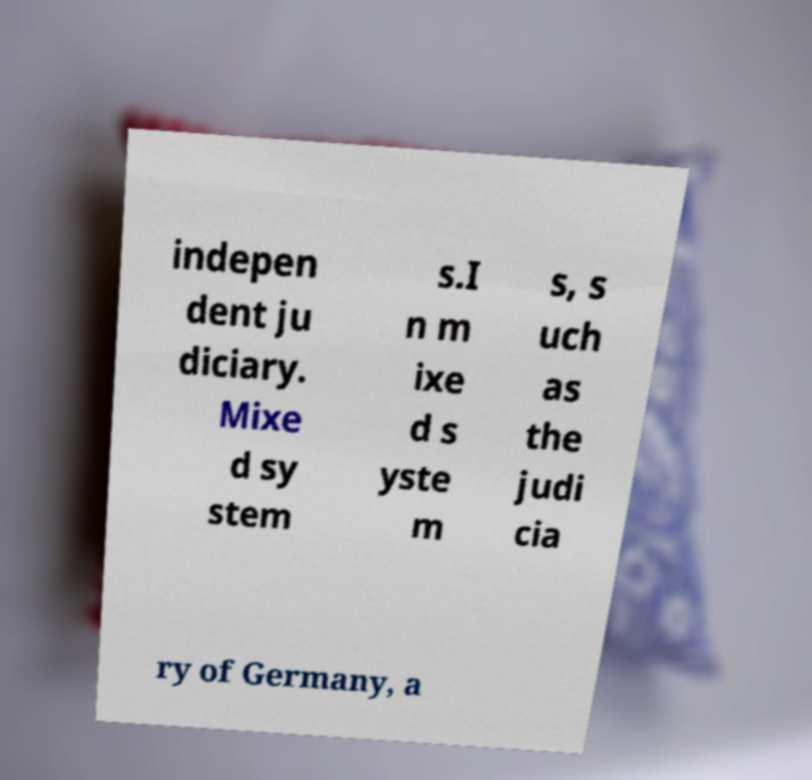Can you read and provide the text displayed in the image?This photo seems to have some interesting text. Can you extract and type it out for me? indepen dent ju diciary. Mixe d sy stem s.I n m ixe d s yste m s, s uch as the judi cia ry of Germany, a 